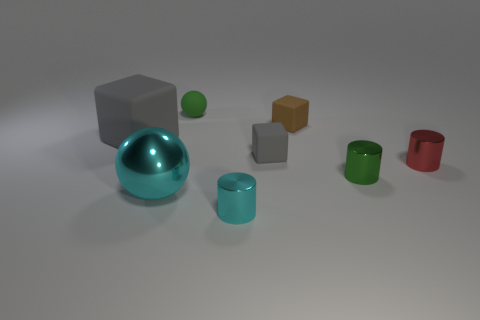What number of large objects are there? In the image, there are two large objects; one appears to be a grey cube and the other a shiny, turquoise sphere. 